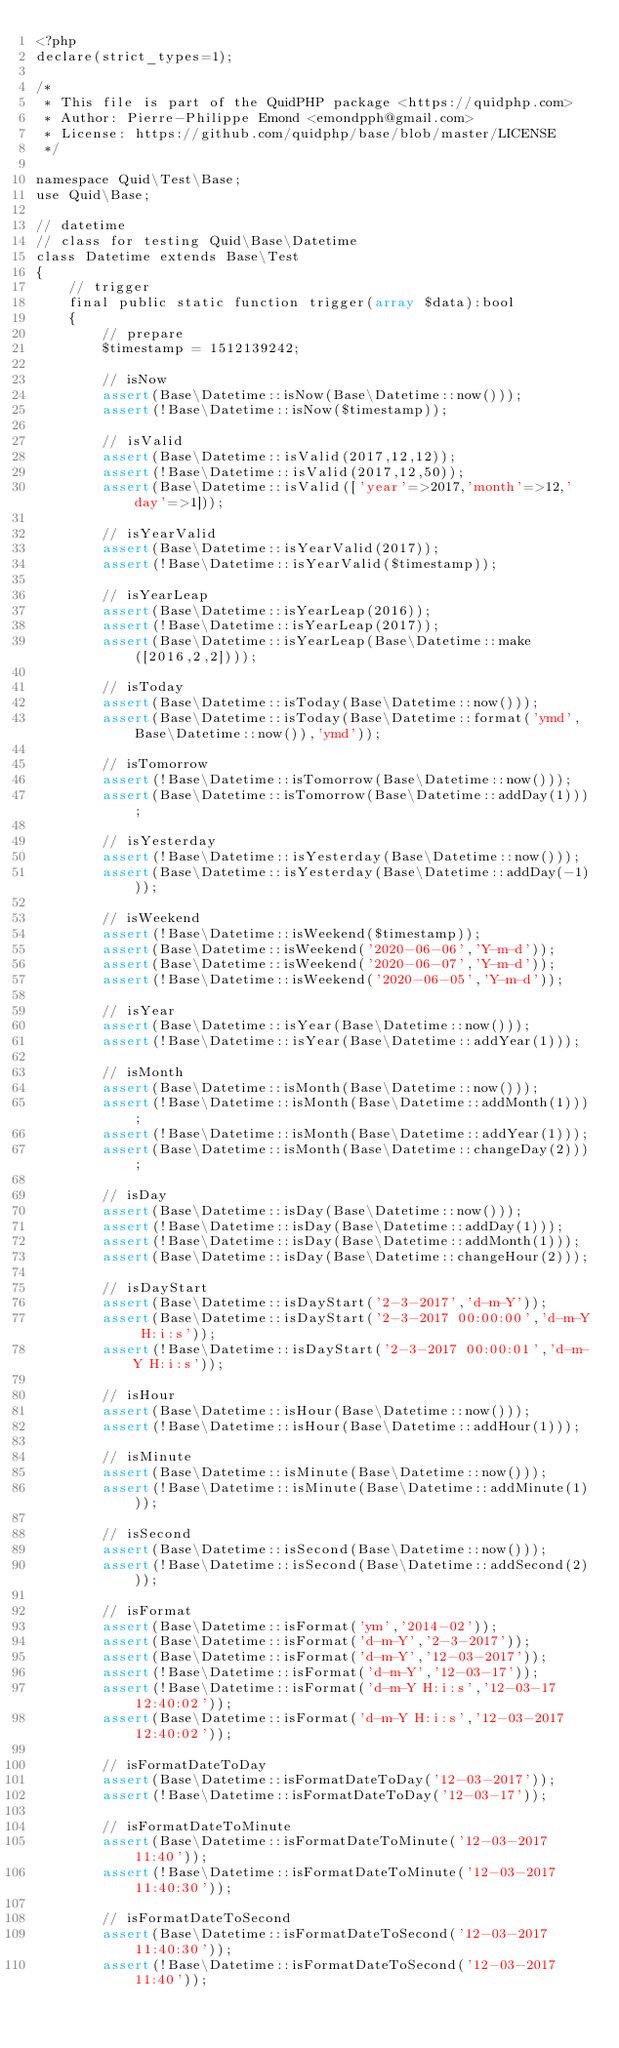Convert code to text. <code><loc_0><loc_0><loc_500><loc_500><_PHP_><?php
declare(strict_types=1);

/*
 * This file is part of the QuidPHP package <https://quidphp.com>
 * Author: Pierre-Philippe Emond <emondpph@gmail.com>
 * License: https://github.com/quidphp/base/blob/master/LICENSE
 */

namespace Quid\Test\Base;
use Quid\Base;

// datetime
// class for testing Quid\Base\Datetime
class Datetime extends Base\Test
{
    // trigger
    final public static function trigger(array $data):bool
    {
        // prepare
        $timestamp = 1512139242;

        // isNow
        assert(Base\Datetime::isNow(Base\Datetime::now()));
        assert(!Base\Datetime::isNow($timestamp));

        // isValid
        assert(Base\Datetime::isValid(2017,12,12));
        assert(!Base\Datetime::isValid(2017,12,50));
        assert(Base\Datetime::isValid(['year'=>2017,'month'=>12,'day'=>1]));

        // isYearValid
        assert(Base\Datetime::isYearValid(2017));
        assert(!Base\Datetime::isYearValid($timestamp));

        // isYearLeap
        assert(Base\Datetime::isYearLeap(2016));
        assert(!Base\Datetime::isYearLeap(2017));
        assert(Base\Datetime::isYearLeap(Base\Datetime::make([2016,2,2])));

        // isToday
        assert(Base\Datetime::isToday(Base\Datetime::now()));
        assert(Base\Datetime::isToday(Base\Datetime::format('ymd',Base\Datetime::now()),'ymd'));

        // isTomorrow
        assert(!Base\Datetime::isTomorrow(Base\Datetime::now()));
        assert(Base\Datetime::isTomorrow(Base\Datetime::addDay(1)));

        // isYesterday
        assert(!Base\Datetime::isYesterday(Base\Datetime::now()));
        assert(Base\Datetime::isYesterday(Base\Datetime::addDay(-1)));

        // isWeekend
        assert(!Base\Datetime::isWeekend($timestamp));
        assert(Base\Datetime::isWeekend('2020-06-06','Y-m-d'));
        assert(Base\Datetime::isWeekend('2020-06-07','Y-m-d'));
        assert(!Base\Datetime::isWeekend('2020-06-05','Y-m-d'));

        // isYear
        assert(Base\Datetime::isYear(Base\Datetime::now()));
        assert(!Base\Datetime::isYear(Base\Datetime::addYear(1)));

        // isMonth
        assert(Base\Datetime::isMonth(Base\Datetime::now()));
        assert(!Base\Datetime::isMonth(Base\Datetime::addMonth(1)));
        assert(!Base\Datetime::isMonth(Base\Datetime::addYear(1)));
        assert(Base\Datetime::isMonth(Base\Datetime::changeDay(2)));

        // isDay
        assert(Base\Datetime::isDay(Base\Datetime::now()));
        assert(!Base\Datetime::isDay(Base\Datetime::addDay(1)));
        assert(!Base\Datetime::isDay(Base\Datetime::addMonth(1)));
        assert(Base\Datetime::isDay(Base\Datetime::changeHour(2)));

        // isDayStart
        assert(Base\Datetime::isDayStart('2-3-2017','d-m-Y'));
        assert(Base\Datetime::isDayStart('2-3-2017 00:00:00','d-m-Y H:i:s'));
        assert(!Base\Datetime::isDayStart('2-3-2017 00:00:01','d-m-Y H:i:s'));

        // isHour
        assert(Base\Datetime::isHour(Base\Datetime::now()));
        assert(!Base\Datetime::isHour(Base\Datetime::addHour(1)));

        // isMinute
        assert(Base\Datetime::isMinute(Base\Datetime::now()));
        assert(!Base\Datetime::isMinute(Base\Datetime::addMinute(1)));

        // isSecond
        assert(Base\Datetime::isSecond(Base\Datetime::now()));
        assert(!Base\Datetime::isSecond(Base\Datetime::addSecond(2)));

        // isFormat
        assert(Base\Datetime::isFormat('ym','2014-02'));
        assert(Base\Datetime::isFormat('d-m-Y','2-3-2017'));
        assert(Base\Datetime::isFormat('d-m-Y','12-03-2017'));
        assert(!Base\Datetime::isFormat('d-m-Y','12-03-17'));
        assert(!Base\Datetime::isFormat('d-m-Y H:i:s','12-03-17 12:40:02'));
        assert(Base\Datetime::isFormat('d-m-Y H:i:s','12-03-2017 12:40:02'));

        // isFormatDateToDay
        assert(Base\Datetime::isFormatDateToDay('12-03-2017'));
        assert(!Base\Datetime::isFormatDateToDay('12-03-17'));

        // isFormatDateToMinute
        assert(Base\Datetime::isFormatDateToMinute('12-03-2017 11:40'));
        assert(!Base\Datetime::isFormatDateToMinute('12-03-2017 11:40:30'));

        // isFormatDateToSecond
        assert(Base\Datetime::isFormatDateToSecond('12-03-2017 11:40:30'));
        assert(!Base\Datetime::isFormatDateToSecond('12-03-2017 11:40'));
</code> 